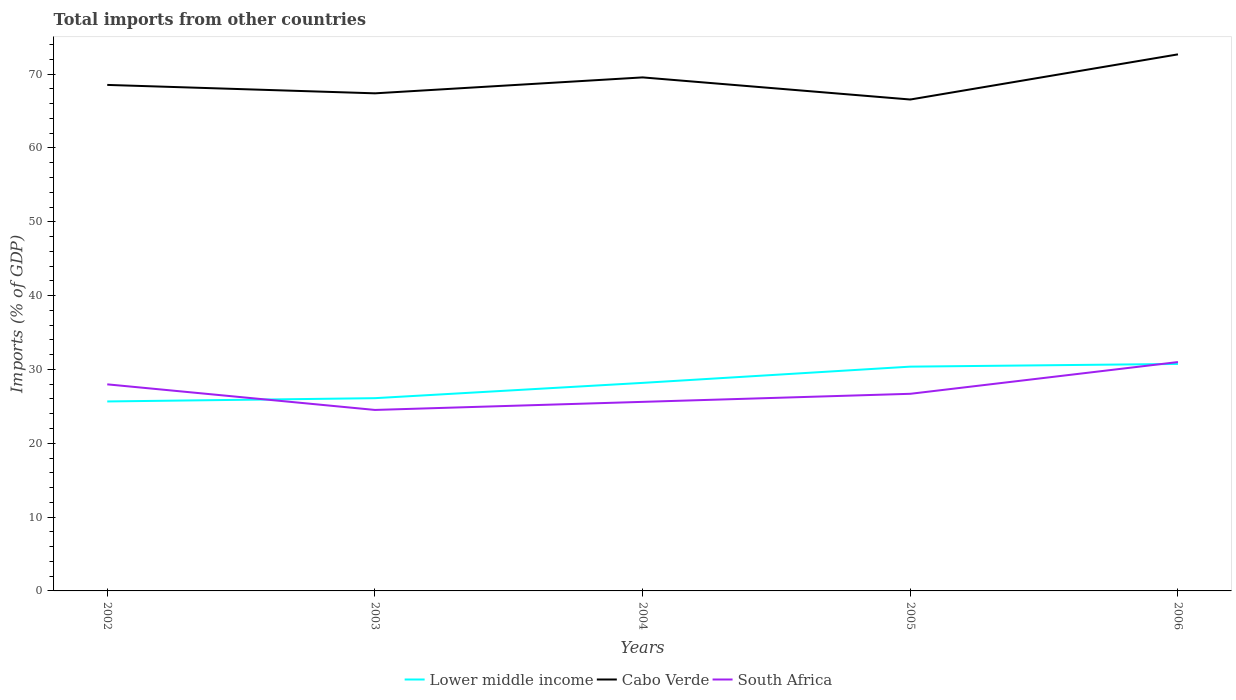Does the line corresponding to South Africa intersect with the line corresponding to Cabo Verde?
Provide a short and direct response. No. Is the number of lines equal to the number of legend labels?
Give a very brief answer. Yes. Across all years, what is the maximum total imports in South Africa?
Provide a succinct answer. 24.52. In which year was the total imports in Cabo Verde maximum?
Provide a short and direct response. 2005. What is the total total imports in Lower middle income in the graph?
Your answer should be very brief. -5.08. What is the difference between the highest and the second highest total imports in Cabo Verde?
Your answer should be very brief. 6.12. What is the difference between the highest and the lowest total imports in Cabo Verde?
Give a very brief answer. 2. Is the total imports in Lower middle income strictly greater than the total imports in Cabo Verde over the years?
Give a very brief answer. Yes. How many lines are there?
Your answer should be very brief. 3. Where does the legend appear in the graph?
Offer a very short reply. Bottom center. How many legend labels are there?
Provide a short and direct response. 3. What is the title of the graph?
Make the answer very short. Total imports from other countries. Does "Belgium" appear as one of the legend labels in the graph?
Ensure brevity in your answer.  No. What is the label or title of the Y-axis?
Give a very brief answer. Imports (% of GDP). What is the Imports (% of GDP) in Lower middle income in 2002?
Your answer should be compact. 25.67. What is the Imports (% of GDP) of Cabo Verde in 2002?
Provide a succinct answer. 68.54. What is the Imports (% of GDP) of South Africa in 2002?
Your response must be concise. 27.98. What is the Imports (% of GDP) in Lower middle income in 2003?
Your response must be concise. 26.11. What is the Imports (% of GDP) of Cabo Verde in 2003?
Your answer should be compact. 67.4. What is the Imports (% of GDP) of South Africa in 2003?
Ensure brevity in your answer.  24.52. What is the Imports (% of GDP) in Lower middle income in 2004?
Your response must be concise. 28.18. What is the Imports (% of GDP) of Cabo Verde in 2004?
Your answer should be very brief. 69.56. What is the Imports (% of GDP) of South Africa in 2004?
Make the answer very short. 25.61. What is the Imports (% of GDP) of Lower middle income in 2005?
Keep it short and to the point. 30.38. What is the Imports (% of GDP) in Cabo Verde in 2005?
Your answer should be compact. 66.57. What is the Imports (% of GDP) of South Africa in 2005?
Provide a short and direct response. 26.7. What is the Imports (% of GDP) in Lower middle income in 2006?
Make the answer very short. 30.75. What is the Imports (% of GDP) in Cabo Verde in 2006?
Offer a terse response. 72.68. What is the Imports (% of GDP) of South Africa in 2006?
Your response must be concise. 31. Across all years, what is the maximum Imports (% of GDP) of Lower middle income?
Your response must be concise. 30.75. Across all years, what is the maximum Imports (% of GDP) in Cabo Verde?
Make the answer very short. 72.68. Across all years, what is the maximum Imports (% of GDP) of South Africa?
Provide a succinct answer. 31. Across all years, what is the minimum Imports (% of GDP) of Lower middle income?
Make the answer very short. 25.67. Across all years, what is the minimum Imports (% of GDP) in Cabo Verde?
Make the answer very short. 66.57. Across all years, what is the minimum Imports (% of GDP) of South Africa?
Provide a succinct answer. 24.52. What is the total Imports (% of GDP) of Lower middle income in the graph?
Offer a terse response. 141.09. What is the total Imports (% of GDP) of Cabo Verde in the graph?
Offer a terse response. 344.76. What is the total Imports (% of GDP) of South Africa in the graph?
Give a very brief answer. 135.82. What is the difference between the Imports (% of GDP) in Lower middle income in 2002 and that in 2003?
Your answer should be very brief. -0.44. What is the difference between the Imports (% of GDP) of Cabo Verde in 2002 and that in 2003?
Provide a succinct answer. 1.14. What is the difference between the Imports (% of GDP) in South Africa in 2002 and that in 2003?
Your answer should be compact. 3.47. What is the difference between the Imports (% of GDP) of Lower middle income in 2002 and that in 2004?
Your answer should be compact. -2.52. What is the difference between the Imports (% of GDP) in Cabo Verde in 2002 and that in 2004?
Offer a terse response. -1.02. What is the difference between the Imports (% of GDP) of South Africa in 2002 and that in 2004?
Keep it short and to the point. 2.37. What is the difference between the Imports (% of GDP) of Lower middle income in 2002 and that in 2005?
Give a very brief answer. -4.72. What is the difference between the Imports (% of GDP) of Cabo Verde in 2002 and that in 2005?
Your response must be concise. 1.98. What is the difference between the Imports (% of GDP) in South Africa in 2002 and that in 2005?
Keep it short and to the point. 1.28. What is the difference between the Imports (% of GDP) in Lower middle income in 2002 and that in 2006?
Provide a succinct answer. -5.08. What is the difference between the Imports (% of GDP) of Cabo Verde in 2002 and that in 2006?
Offer a terse response. -4.14. What is the difference between the Imports (% of GDP) of South Africa in 2002 and that in 2006?
Provide a succinct answer. -3.02. What is the difference between the Imports (% of GDP) of Lower middle income in 2003 and that in 2004?
Offer a very short reply. -2.07. What is the difference between the Imports (% of GDP) of Cabo Verde in 2003 and that in 2004?
Make the answer very short. -2.16. What is the difference between the Imports (% of GDP) in South Africa in 2003 and that in 2004?
Make the answer very short. -1.09. What is the difference between the Imports (% of GDP) of Lower middle income in 2003 and that in 2005?
Give a very brief answer. -4.27. What is the difference between the Imports (% of GDP) of Cabo Verde in 2003 and that in 2005?
Offer a very short reply. 0.84. What is the difference between the Imports (% of GDP) in South Africa in 2003 and that in 2005?
Offer a very short reply. -2.19. What is the difference between the Imports (% of GDP) in Lower middle income in 2003 and that in 2006?
Your answer should be very brief. -4.64. What is the difference between the Imports (% of GDP) in Cabo Verde in 2003 and that in 2006?
Your answer should be very brief. -5.28. What is the difference between the Imports (% of GDP) of South Africa in 2003 and that in 2006?
Your answer should be compact. -6.49. What is the difference between the Imports (% of GDP) in Lower middle income in 2004 and that in 2005?
Your answer should be compact. -2.2. What is the difference between the Imports (% of GDP) in Cabo Verde in 2004 and that in 2005?
Your response must be concise. 3. What is the difference between the Imports (% of GDP) of South Africa in 2004 and that in 2005?
Your answer should be compact. -1.09. What is the difference between the Imports (% of GDP) in Lower middle income in 2004 and that in 2006?
Make the answer very short. -2.56. What is the difference between the Imports (% of GDP) in Cabo Verde in 2004 and that in 2006?
Offer a terse response. -3.12. What is the difference between the Imports (% of GDP) of South Africa in 2004 and that in 2006?
Ensure brevity in your answer.  -5.39. What is the difference between the Imports (% of GDP) in Lower middle income in 2005 and that in 2006?
Provide a succinct answer. -0.36. What is the difference between the Imports (% of GDP) of Cabo Verde in 2005 and that in 2006?
Your answer should be very brief. -6.12. What is the difference between the Imports (% of GDP) of South Africa in 2005 and that in 2006?
Keep it short and to the point. -4.3. What is the difference between the Imports (% of GDP) of Lower middle income in 2002 and the Imports (% of GDP) of Cabo Verde in 2003?
Give a very brief answer. -41.74. What is the difference between the Imports (% of GDP) of Lower middle income in 2002 and the Imports (% of GDP) of South Africa in 2003?
Ensure brevity in your answer.  1.15. What is the difference between the Imports (% of GDP) in Cabo Verde in 2002 and the Imports (% of GDP) in South Africa in 2003?
Provide a succinct answer. 44.03. What is the difference between the Imports (% of GDP) in Lower middle income in 2002 and the Imports (% of GDP) in Cabo Verde in 2004?
Provide a succinct answer. -43.9. What is the difference between the Imports (% of GDP) in Lower middle income in 2002 and the Imports (% of GDP) in South Africa in 2004?
Your answer should be compact. 0.05. What is the difference between the Imports (% of GDP) in Cabo Verde in 2002 and the Imports (% of GDP) in South Africa in 2004?
Give a very brief answer. 42.93. What is the difference between the Imports (% of GDP) of Lower middle income in 2002 and the Imports (% of GDP) of Cabo Verde in 2005?
Your response must be concise. -40.9. What is the difference between the Imports (% of GDP) of Lower middle income in 2002 and the Imports (% of GDP) of South Africa in 2005?
Make the answer very short. -1.04. What is the difference between the Imports (% of GDP) of Cabo Verde in 2002 and the Imports (% of GDP) of South Africa in 2005?
Ensure brevity in your answer.  41.84. What is the difference between the Imports (% of GDP) of Lower middle income in 2002 and the Imports (% of GDP) of Cabo Verde in 2006?
Your answer should be compact. -47.02. What is the difference between the Imports (% of GDP) of Lower middle income in 2002 and the Imports (% of GDP) of South Africa in 2006?
Provide a succinct answer. -5.34. What is the difference between the Imports (% of GDP) of Cabo Verde in 2002 and the Imports (% of GDP) of South Africa in 2006?
Your response must be concise. 37.54. What is the difference between the Imports (% of GDP) of Lower middle income in 2003 and the Imports (% of GDP) of Cabo Verde in 2004?
Make the answer very short. -43.45. What is the difference between the Imports (% of GDP) in Lower middle income in 2003 and the Imports (% of GDP) in South Africa in 2004?
Keep it short and to the point. 0.5. What is the difference between the Imports (% of GDP) of Cabo Verde in 2003 and the Imports (% of GDP) of South Africa in 2004?
Give a very brief answer. 41.79. What is the difference between the Imports (% of GDP) in Lower middle income in 2003 and the Imports (% of GDP) in Cabo Verde in 2005?
Provide a short and direct response. -40.46. What is the difference between the Imports (% of GDP) of Lower middle income in 2003 and the Imports (% of GDP) of South Africa in 2005?
Keep it short and to the point. -0.59. What is the difference between the Imports (% of GDP) of Cabo Verde in 2003 and the Imports (% of GDP) of South Africa in 2005?
Provide a short and direct response. 40.7. What is the difference between the Imports (% of GDP) of Lower middle income in 2003 and the Imports (% of GDP) of Cabo Verde in 2006?
Make the answer very short. -46.57. What is the difference between the Imports (% of GDP) in Lower middle income in 2003 and the Imports (% of GDP) in South Africa in 2006?
Provide a succinct answer. -4.89. What is the difference between the Imports (% of GDP) of Cabo Verde in 2003 and the Imports (% of GDP) of South Africa in 2006?
Offer a very short reply. 36.4. What is the difference between the Imports (% of GDP) in Lower middle income in 2004 and the Imports (% of GDP) in Cabo Verde in 2005?
Your answer should be compact. -38.38. What is the difference between the Imports (% of GDP) of Lower middle income in 2004 and the Imports (% of GDP) of South Africa in 2005?
Provide a short and direct response. 1.48. What is the difference between the Imports (% of GDP) in Cabo Verde in 2004 and the Imports (% of GDP) in South Africa in 2005?
Your answer should be compact. 42.86. What is the difference between the Imports (% of GDP) in Lower middle income in 2004 and the Imports (% of GDP) in Cabo Verde in 2006?
Offer a very short reply. -44.5. What is the difference between the Imports (% of GDP) of Lower middle income in 2004 and the Imports (% of GDP) of South Africa in 2006?
Your response must be concise. -2.82. What is the difference between the Imports (% of GDP) in Cabo Verde in 2004 and the Imports (% of GDP) in South Africa in 2006?
Your response must be concise. 38.56. What is the difference between the Imports (% of GDP) of Lower middle income in 2005 and the Imports (% of GDP) of Cabo Verde in 2006?
Your response must be concise. -42.3. What is the difference between the Imports (% of GDP) of Lower middle income in 2005 and the Imports (% of GDP) of South Africa in 2006?
Your answer should be compact. -0.62. What is the difference between the Imports (% of GDP) of Cabo Verde in 2005 and the Imports (% of GDP) of South Africa in 2006?
Provide a short and direct response. 35.56. What is the average Imports (% of GDP) of Lower middle income per year?
Your answer should be very brief. 28.22. What is the average Imports (% of GDP) in Cabo Verde per year?
Your response must be concise. 68.95. What is the average Imports (% of GDP) of South Africa per year?
Provide a succinct answer. 27.16. In the year 2002, what is the difference between the Imports (% of GDP) of Lower middle income and Imports (% of GDP) of Cabo Verde?
Give a very brief answer. -42.88. In the year 2002, what is the difference between the Imports (% of GDP) of Lower middle income and Imports (% of GDP) of South Africa?
Offer a very short reply. -2.32. In the year 2002, what is the difference between the Imports (% of GDP) of Cabo Verde and Imports (% of GDP) of South Africa?
Your response must be concise. 40.56. In the year 2003, what is the difference between the Imports (% of GDP) in Lower middle income and Imports (% of GDP) in Cabo Verde?
Give a very brief answer. -41.29. In the year 2003, what is the difference between the Imports (% of GDP) of Lower middle income and Imports (% of GDP) of South Africa?
Your answer should be compact. 1.59. In the year 2003, what is the difference between the Imports (% of GDP) in Cabo Verde and Imports (% of GDP) in South Africa?
Offer a terse response. 42.89. In the year 2004, what is the difference between the Imports (% of GDP) in Lower middle income and Imports (% of GDP) in Cabo Verde?
Your answer should be compact. -41.38. In the year 2004, what is the difference between the Imports (% of GDP) of Lower middle income and Imports (% of GDP) of South Africa?
Give a very brief answer. 2.57. In the year 2004, what is the difference between the Imports (% of GDP) of Cabo Verde and Imports (% of GDP) of South Africa?
Keep it short and to the point. 43.95. In the year 2005, what is the difference between the Imports (% of GDP) of Lower middle income and Imports (% of GDP) of Cabo Verde?
Make the answer very short. -36.18. In the year 2005, what is the difference between the Imports (% of GDP) of Lower middle income and Imports (% of GDP) of South Africa?
Provide a short and direct response. 3.68. In the year 2005, what is the difference between the Imports (% of GDP) in Cabo Verde and Imports (% of GDP) in South Africa?
Ensure brevity in your answer.  39.86. In the year 2006, what is the difference between the Imports (% of GDP) in Lower middle income and Imports (% of GDP) in Cabo Verde?
Offer a very short reply. -41.94. In the year 2006, what is the difference between the Imports (% of GDP) in Lower middle income and Imports (% of GDP) in South Africa?
Keep it short and to the point. -0.26. In the year 2006, what is the difference between the Imports (% of GDP) of Cabo Verde and Imports (% of GDP) of South Africa?
Keep it short and to the point. 41.68. What is the ratio of the Imports (% of GDP) of Cabo Verde in 2002 to that in 2003?
Give a very brief answer. 1.02. What is the ratio of the Imports (% of GDP) of South Africa in 2002 to that in 2003?
Give a very brief answer. 1.14. What is the ratio of the Imports (% of GDP) in Lower middle income in 2002 to that in 2004?
Keep it short and to the point. 0.91. What is the ratio of the Imports (% of GDP) in Cabo Verde in 2002 to that in 2004?
Your answer should be compact. 0.99. What is the ratio of the Imports (% of GDP) in South Africa in 2002 to that in 2004?
Provide a succinct answer. 1.09. What is the ratio of the Imports (% of GDP) in Lower middle income in 2002 to that in 2005?
Keep it short and to the point. 0.84. What is the ratio of the Imports (% of GDP) in Cabo Verde in 2002 to that in 2005?
Offer a very short reply. 1.03. What is the ratio of the Imports (% of GDP) of South Africa in 2002 to that in 2005?
Give a very brief answer. 1.05. What is the ratio of the Imports (% of GDP) in Lower middle income in 2002 to that in 2006?
Offer a terse response. 0.83. What is the ratio of the Imports (% of GDP) of Cabo Verde in 2002 to that in 2006?
Make the answer very short. 0.94. What is the ratio of the Imports (% of GDP) in South Africa in 2002 to that in 2006?
Ensure brevity in your answer.  0.9. What is the ratio of the Imports (% of GDP) in Lower middle income in 2003 to that in 2004?
Provide a short and direct response. 0.93. What is the ratio of the Imports (% of GDP) in South Africa in 2003 to that in 2004?
Your answer should be very brief. 0.96. What is the ratio of the Imports (% of GDP) of Lower middle income in 2003 to that in 2005?
Provide a succinct answer. 0.86. What is the ratio of the Imports (% of GDP) of Cabo Verde in 2003 to that in 2005?
Provide a succinct answer. 1.01. What is the ratio of the Imports (% of GDP) of South Africa in 2003 to that in 2005?
Offer a very short reply. 0.92. What is the ratio of the Imports (% of GDP) in Lower middle income in 2003 to that in 2006?
Provide a succinct answer. 0.85. What is the ratio of the Imports (% of GDP) of Cabo Verde in 2003 to that in 2006?
Provide a short and direct response. 0.93. What is the ratio of the Imports (% of GDP) of South Africa in 2003 to that in 2006?
Your answer should be compact. 0.79. What is the ratio of the Imports (% of GDP) of Lower middle income in 2004 to that in 2005?
Your answer should be compact. 0.93. What is the ratio of the Imports (% of GDP) of Cabo Verde in 2004 to that in 2005?
Provide a succinct answer. 1.04. What is the ratio of the Imports (% of GDP) of South Africa in 2004 to that in 2005?
Give a very brief answer. 0.96. What is the ratio of the Imports (% of GDP) in Lower middle income in 2004 to that in 2006?
Offer a very short reply. 0.92. What is the ratio of the Imports (% of GDP) of Cabo Verde in 2004 to that in 2006?
Provide a short and direct response. 0.96. What is the ratio of the Imports (% of GDP) of South Africa in 2004 to that in 2006?
Ensure brevity in your answer.  0.83. What is the ratio of the Imports (% of GDP) in Cabo Verde in 2005 to that in 2006?
Provide a short and direct response. 0.92. What is the ratio of the Imports (% of GDP) in South Africa in 2005 to that in 2006?
Offer a very short reply. 0.86. What is the difference between the highest and the second highest Imports (% of GDP) in Lower middle income?
Your response must be concise. 0.36. What is the difference between the highest and the second highest Imports (% of GDP) in Cabo Verde?
Your response must be concise. 3.12. What is the difference between the highest and the second highest Imports (% of GDP) in South Africa?
Give a very brief answer. 3.02. What is the difference between the highest and the lowest Imports (% of GDP) of Lower middle income?
Offer a very short reply. 5.08. What is the difference between the highest and the lowest Imports (% of GDP) of Cabo Verde?
Keep it short and to the point. 6.12. What is the difference between the highest and the lowest Imports (% of GDP) of South Africa?
Ensure brevity in your answer.  6.49. 